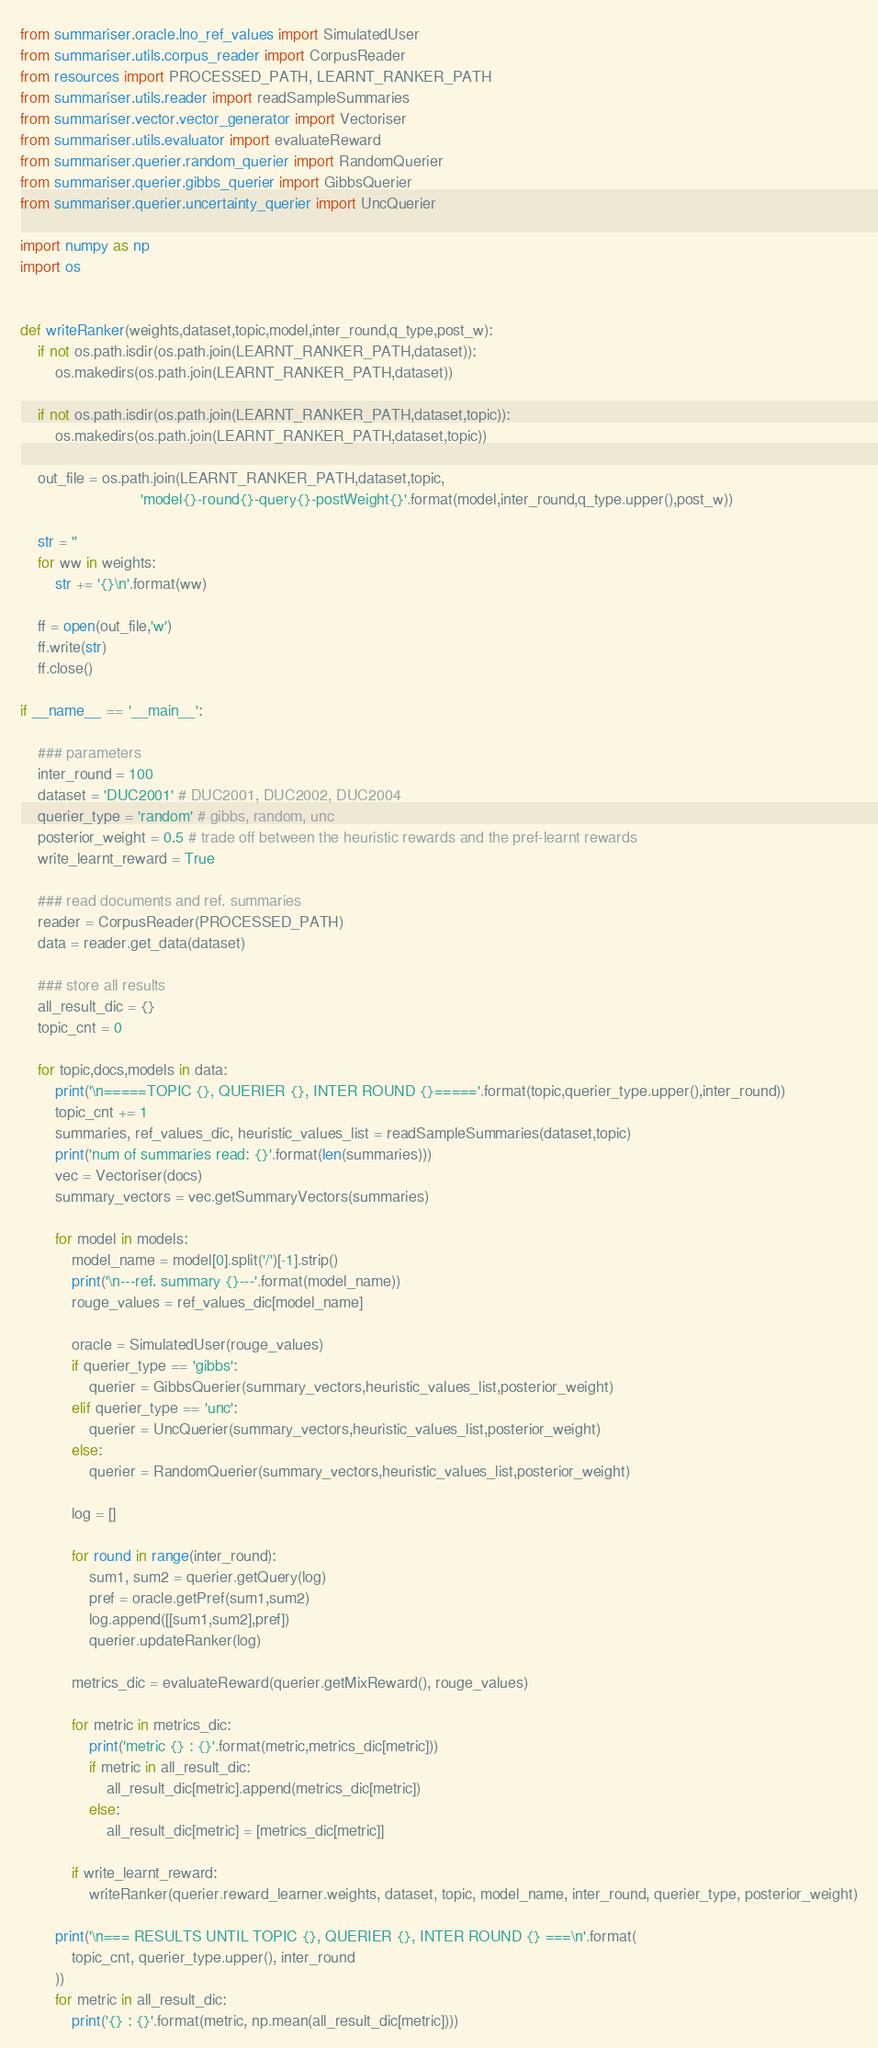Convert code to text. <code><loc_0><loc_0><loc_500><loc_500><_Python_>from summariser.oracle.lno_ref_values import SimulatedUser
from summariser.utils.corpus_reader import CorpusReader
from resources import PROCESSED_PATH, LEARNT_RANKER_PATH
from summariser.utils.reader import readSampleSummaries
from summariser.vector.vector_generator import Vectoriser
from summariser.utils.evaluator import evaluateReward
from summariser.querier.random_querier import RandomQuerier
from summariser.querier.gibbs_querier import GibbsQuerier
from summariser.querier.uncertainty_querier import UncQuerier

import numpy as np
import os


def writeRanker(weights,dataset,topic,model,inter_round,q_type,post_w):
    if not os.path.isdir(os.path.join(LEARNT_RANKER_PATH,dataset)):
        os.makedirs(os.path.join(LEARNT_RANKER_PATH,dataset))

    if not os.path.isdir(os.path.join(LEARNT_RANKER_PATH,dataset,topic)):
        os.makedirs(os.path.join(LEARNT_RANKER_PATH,dataset,topic))

    out_file = os.path.join(LEARNT_RANKER_PATH,dataset,topic,
                            'model{}-round{}-query{}-postWeight{}'.format(model,inter_round,q_type.upper(),post_w))

    str = ''
    for ww in weights:
        str += '{}\n'.format(ww)

    ff = open(out_file,'w')
    ff.write(str)
    ff.close()

if __name__ == '__main__':

    ### parameters
    inter_round = 100
    dataset = 'DUC2001' # DUC2001, DUC2002, DUC2004
    querier_type = 'random' # gibbs, random, unc
    posterior_weight = 0.5 # trade off between the heuristic rewards and the pref-learnt rewards
    write_learnt_reward = True

    ### read documents and ref. summaries
    reader = CorpusReader(PROCESSED_PATH)
    data = reader.get_data(dataset)

    ### store all results
    all_result_dic = {}
    topic_cnt = 0

    for topic,docs,models in data:
        print('\n=====TOPIC {}, QUERIER {}, INTER ROUND {}====='.format(topic,querier_type.upper(),inter_round))
        topic_cnt += 1
        summaries, ref_values_dic, heuristic_values_list = readSampleSummaries(dataset,topic)
        print('num of summaries read: {}'.format(len(summaries)))
        vec = Vectoriser(docs)
        summary_vectors = vec.getSummaryVectors(summaries)

        for model in models:
            model_name = model[0].split('/')[-1].strip()
            print('\n---ref. summary {}---'.format(model_name))
            rouge_values = ref_values_dic[model_name]

            oracle = SimulatedUser(rouge_values)
            if querier_type == 'gibbs':
                querier = GibbsQuerier(summary_vectors,heuristic_values_list,posterior_weight)
            elif querier_type == 'unc':
                querier = UncQuerier(summary_vectors,heuristic_values_list,posterior_weight)
            else:
                querier = RandomQuerier(summary_vectors,heuristic_values_list,posterior_weight)

            log = []

            for round in range(inter_round):
                sum1, sum2 = querier.getQuery(log)
                pref = oracle.getPref(sum1,sum2)
                log.append([[sum1,sum2],pref])
                querier.updateRanker(log)

            metrics_dic = evaluateReward(querier.getMixReward(), rouge_values)

            for metric in metrics_dic:
                print('metric {} : {}'.format(metric,metrics_dic[metric]))
                if metric in all_result_dic:
                    all_result_dic[metric].append(metrics_dic[metric])
                else:
                    all_result_dic[metric] = [metrics_dic[metric]]

            if write_learnt_reward:
                writeRanker(querier.reward_learner.weights, dataset, topic, model_name, inter_round, querier_type, posterior_weight)

        print('\n=== RESULTS UNTIL TOPIC {}, QUERIER {}, INTER ROUND {} ===\n'.format(
            topic_cnt, querier_type.upper(), inter_round
        ))
        for metric in all_result_dic:
            print('{} : {}'.format(metric, np.mean(all_result_dic[metric])))






</code> 